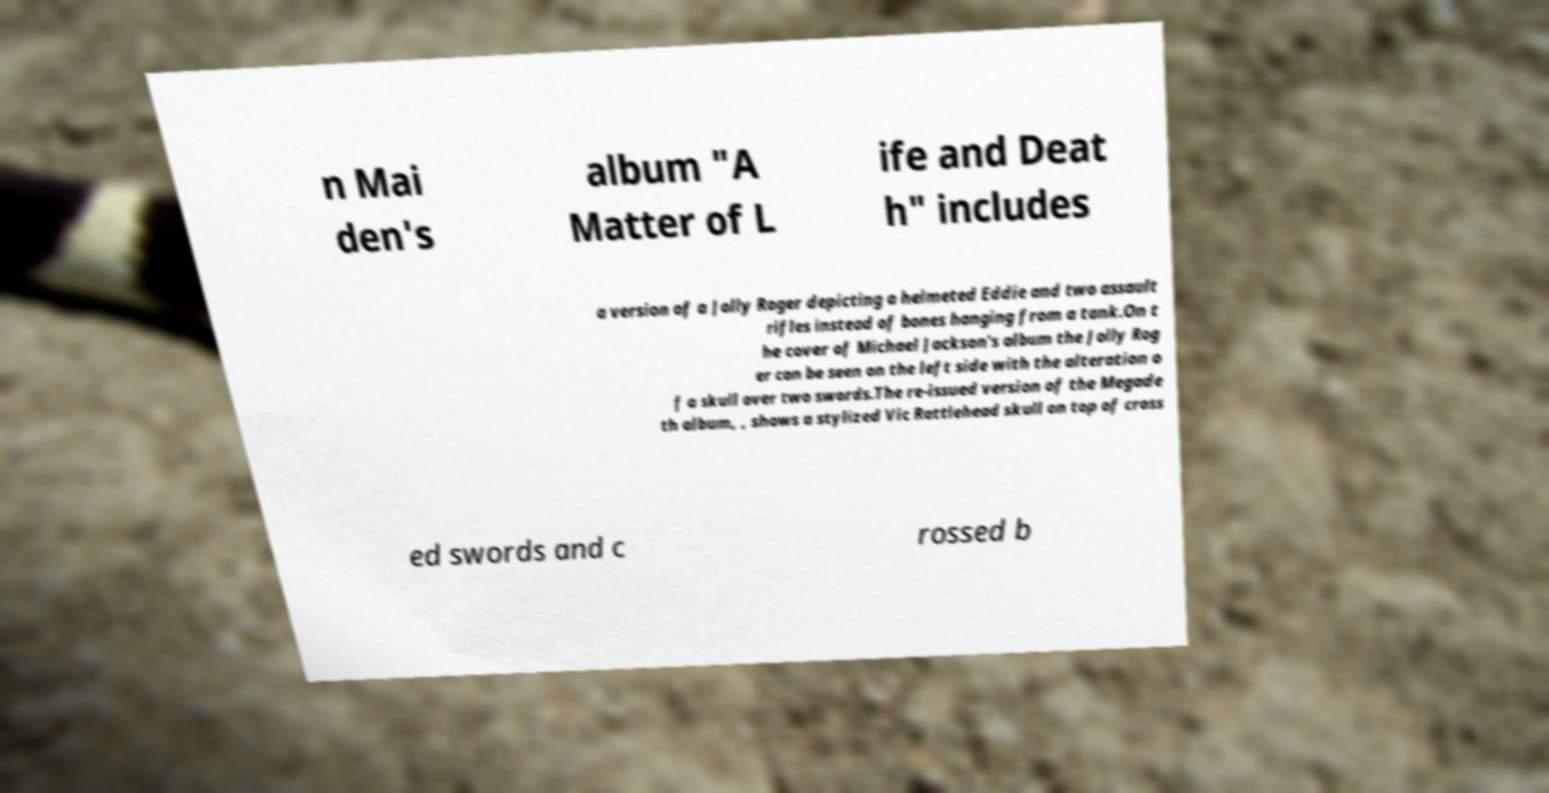What messages or text are displayed in this image? I need them in a readable, typed format. n Mai den's album "A Matter of L ife and Deat h" includes a version of a Jolly Roger depicting a helmeted Eddie and two assault rifles instead of bones hanging from a tank.On t he cover of Michael Jackson's album the Jolly Rog er can be seen on the left side with the alteration o f a skull over two swords.The re-issued version of the Megade th album, , shows a stylized Vic Rattlehead skull on top of cross ed swords and c rossed b 